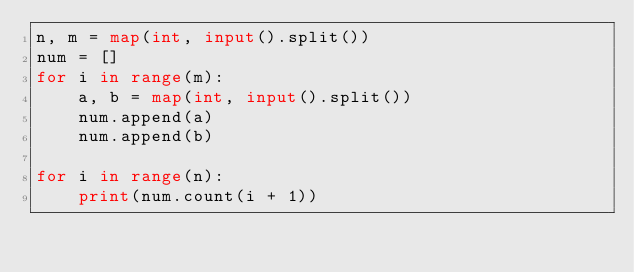<code> <loc_0><loc_0><loc_500><loc_500><_Python_>n, m = map(int, input().split())
num = []
for i in range(m):
    a, b = map(int, input().split())
    num.append(a)
    num.append(b)

for i in range(n):
    print(num.count(i + 1))</code> 